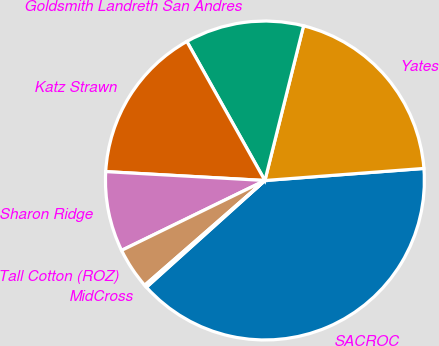<chart> <loc_0><loc_0><loc_500><loc_500><pie_chart><fcel>SACROC<fcel>Yates<fcel>Goldsmith Landreth San Andres<fcel>Katz Strawn<fcel>Sharon Ridge<fcel>Tall Cotton (ROZ)<fcel>MidCross<nl><fcel>39.54%<fcel>19.9%<fcel>12.04%<fcel>15.97%<fcel>8.11%<fcel>4.19%<fcel>0.26%<nl></chart> 